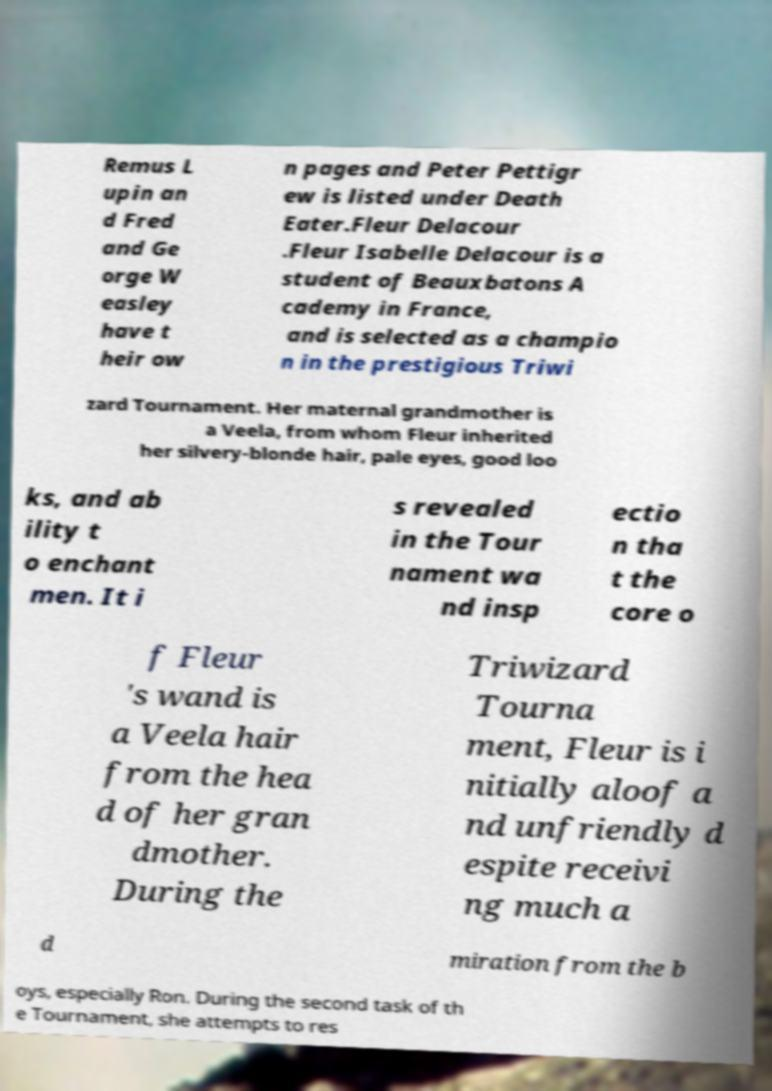Can you accurately transcribe the text from the provided image for me? Remus L upin an d Fred and Ge orge W easley have t heir ow n pages and Peter Pettigr ew is listed under Death Eater.Fleur Delacour .Fleur Isabelle Delacour is a student of Beauxbatons A cademy in France, and is selected as a champio n in the prestigious Triwi zard Tournament. Her maternal grandmother is a Veela, from whom Fleur inherited her silvery-blonde hair, pale eyes, good loo ks, and ab ility t o enchant men. It i s revealed in the Tour nament wa nd insp ectio n tha t the core o f Fleur 's wand is a Veela hair from the hea d of her gran dmother. During the Triwizard Tourna ment, Fleur is i nitially aloof a nd unfriendly d espite receivi ng much a d miration from the b oys, especially Ron. During the second task of th e Tournament, she attempts to res 